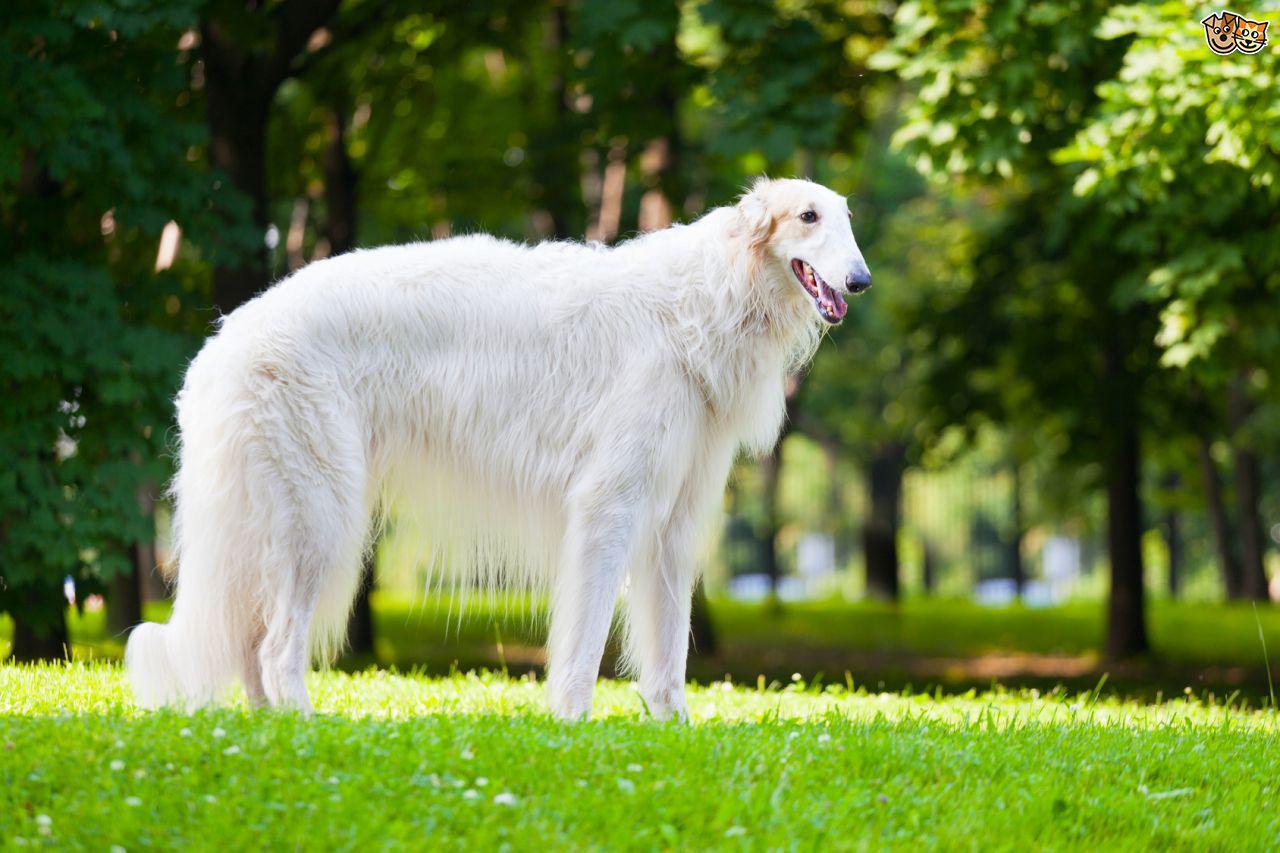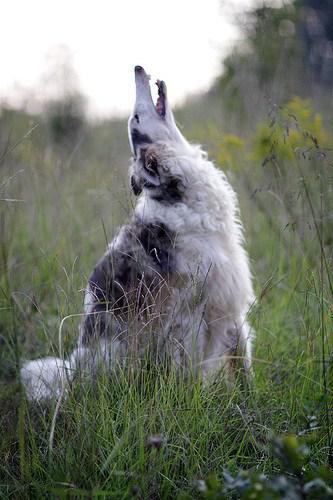The first image is the image on the left, the second image is the image on the right. Analyze the images presented: Is the assertion "All dogs in the images are on the grass." valid? Answer yes or no. Yes. 